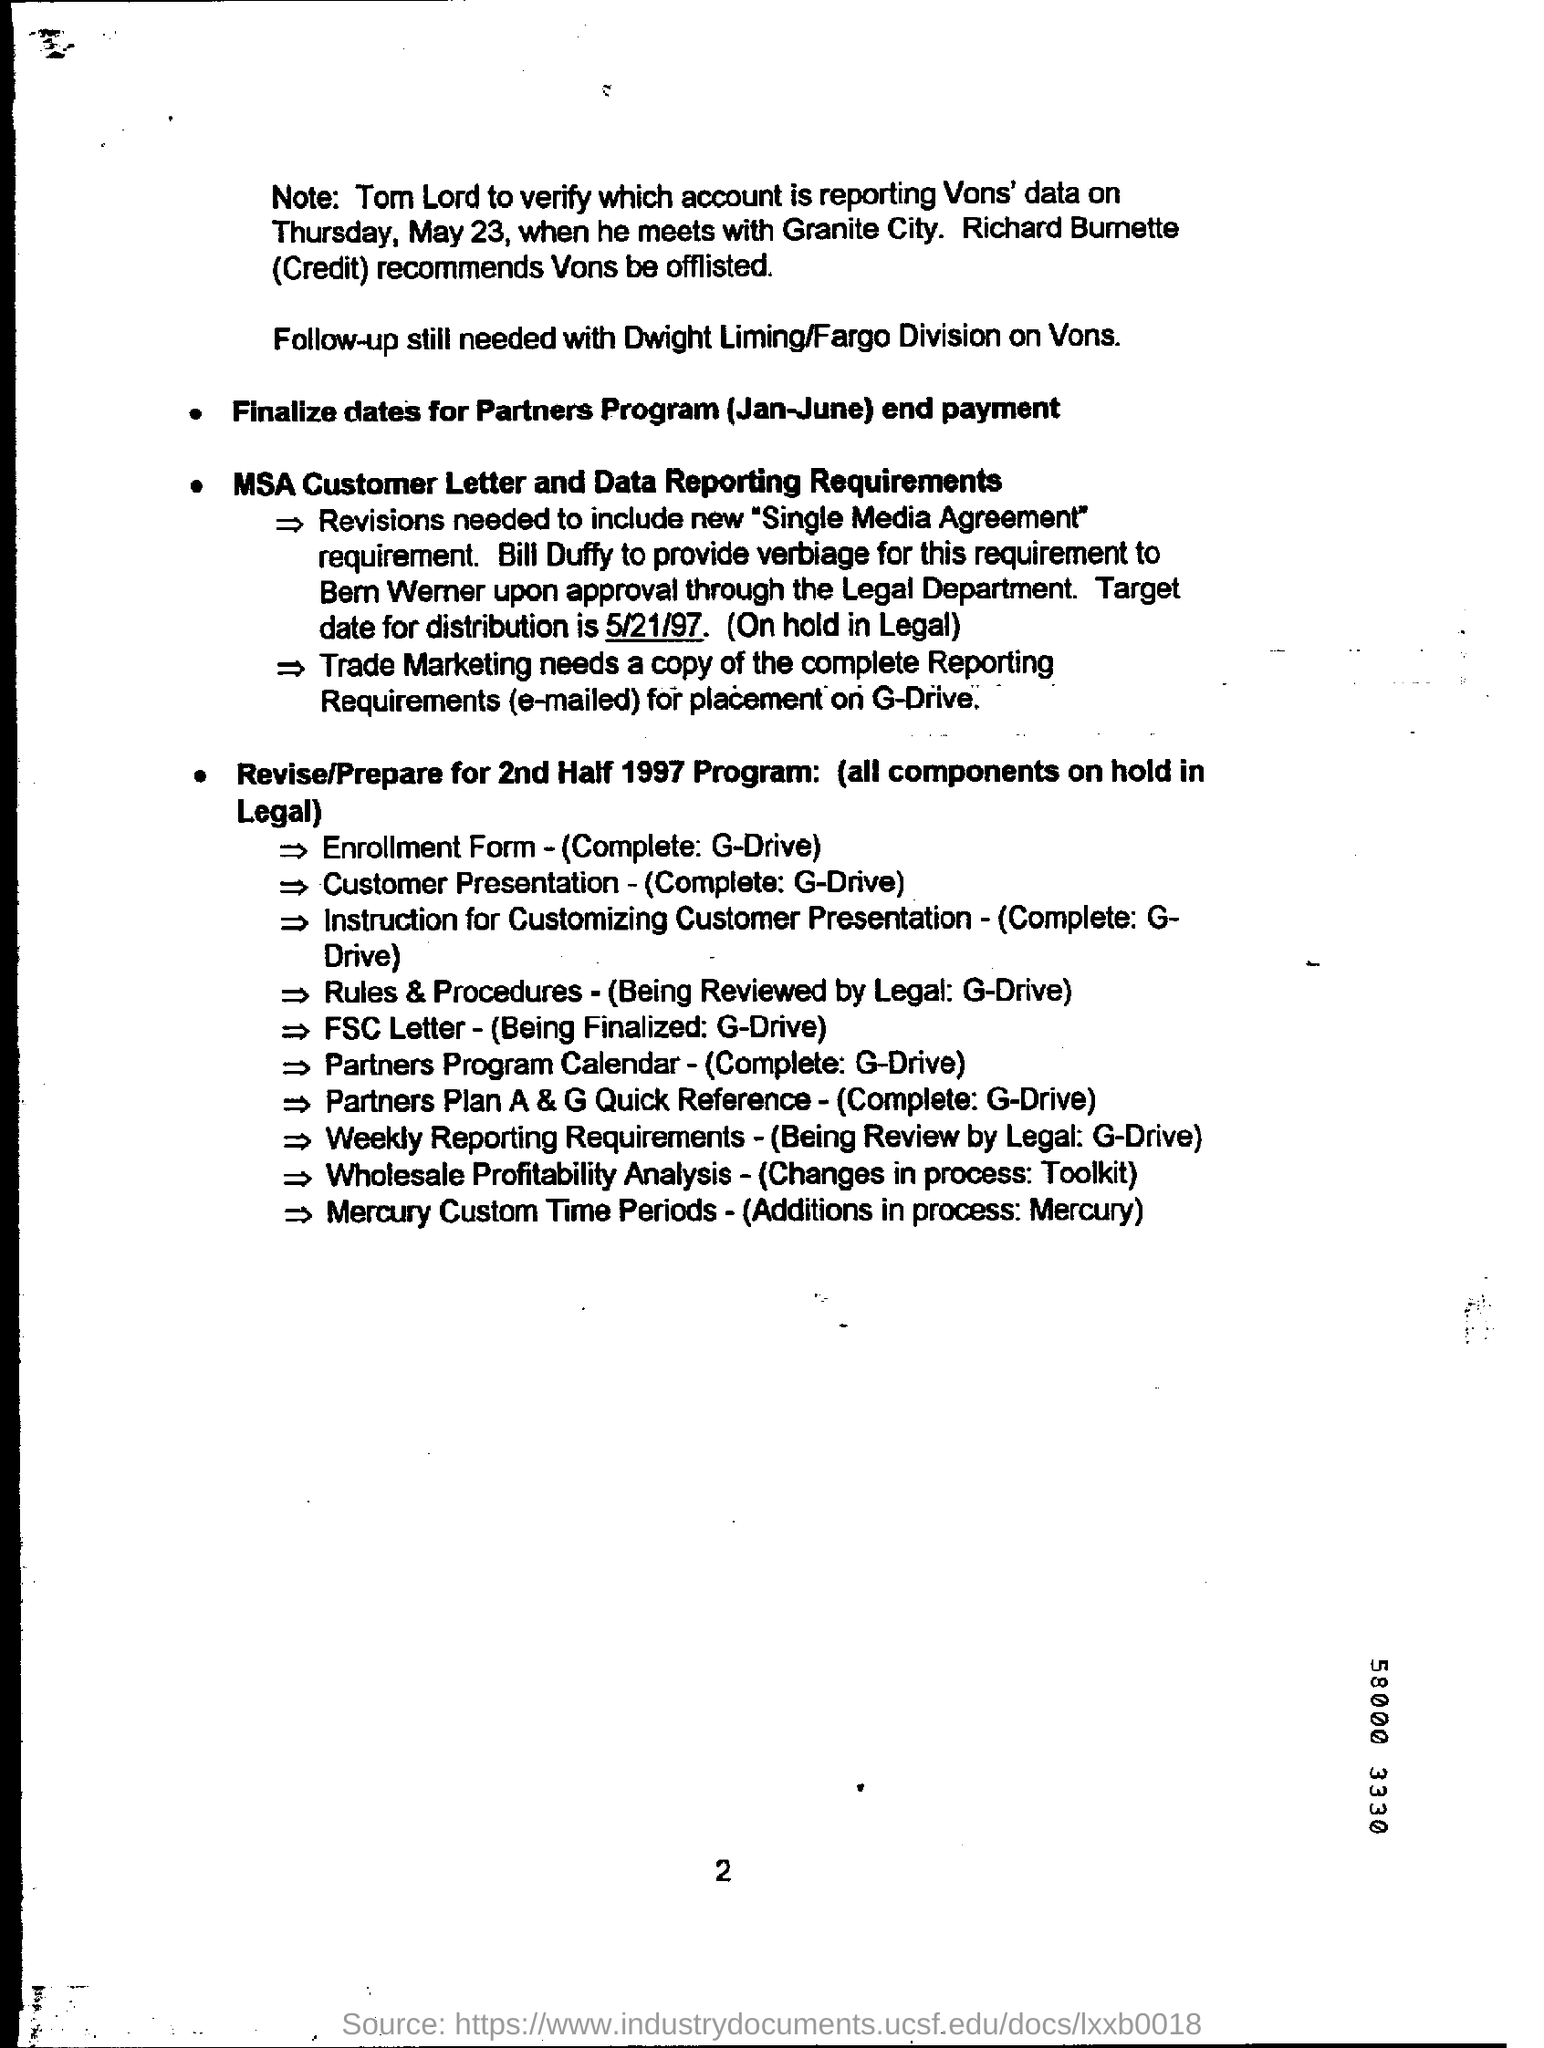Who recommends Vans be offlisted?
Provide a short and direct response. Richard Bumette. What is the target date for the distribution?
Your answer should be compact. 5/21/97. 